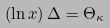Convert formula to latex. <formula><loc_0><loc_0><loc_500><loc_500>( \ln x ) \, \Delta = \Theta _ { \kappa }</formula> 